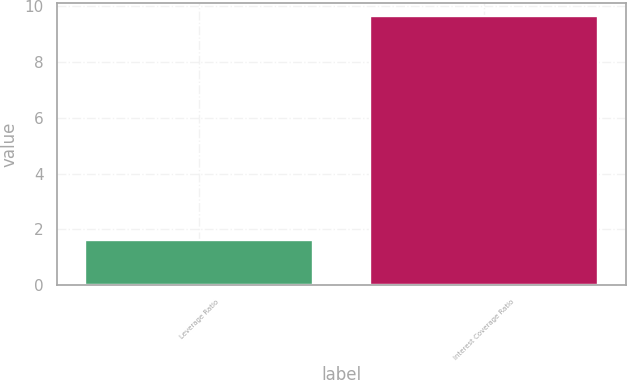<chart> <loc_0><loc_0><loc_500><loc_500><bar_chart><fcel>Leverage Ratio<fcel>Interest Coverage Ratio<nl><fcel>1.63<fcel>9.64<nl></chart> 